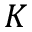Convert formula to latex. <formula><loc_0><loc_0><loc_500><loc_500>K</formula> 